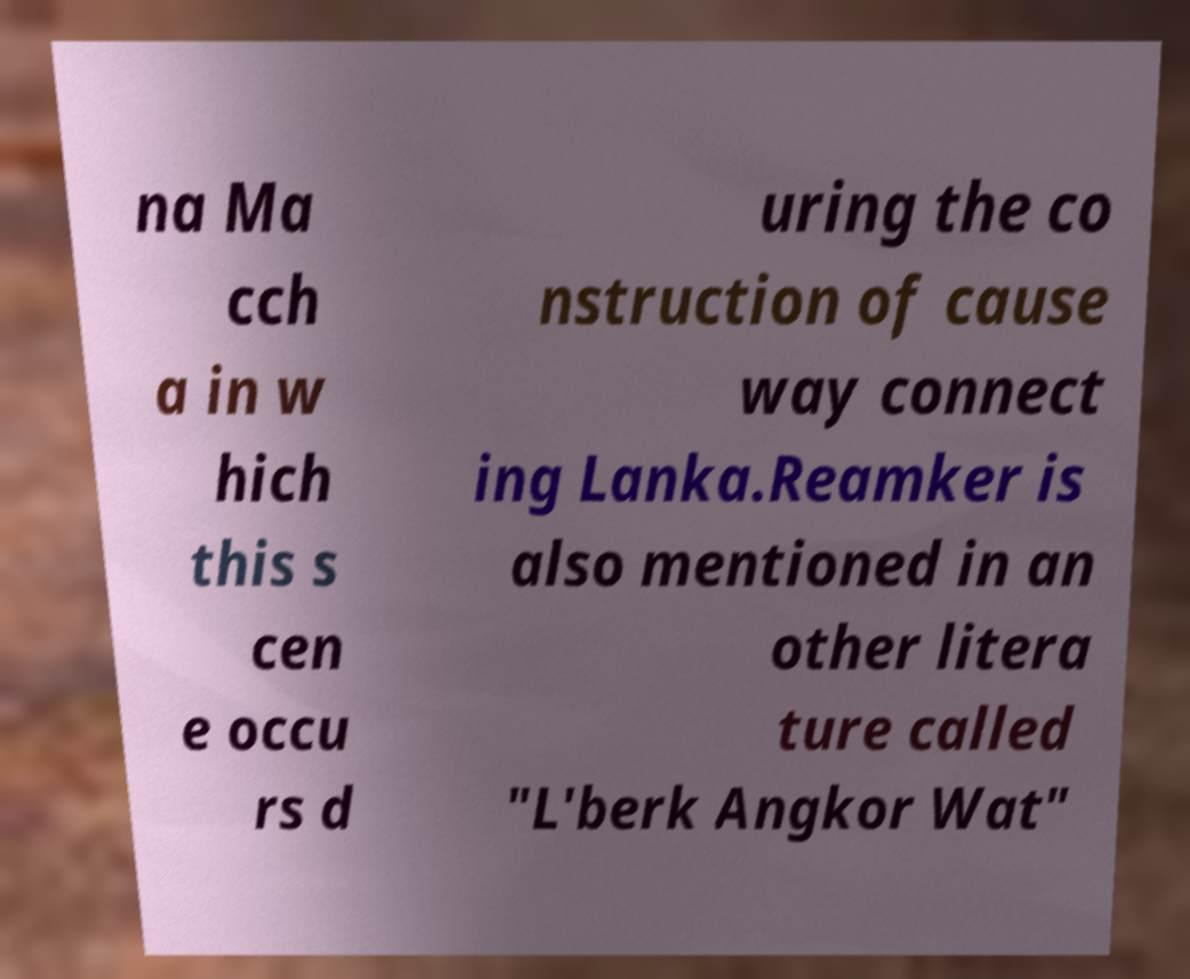There's text embedded in this image that I need extracted. Can you transcribe it verbatim? na Ma cch a in w hich this s cen e occu rs d uring the co nstruction of cause way connect ing Lanka.Reamker is also mentioned in an other litera ture called "L'berk Angkor Wat" 